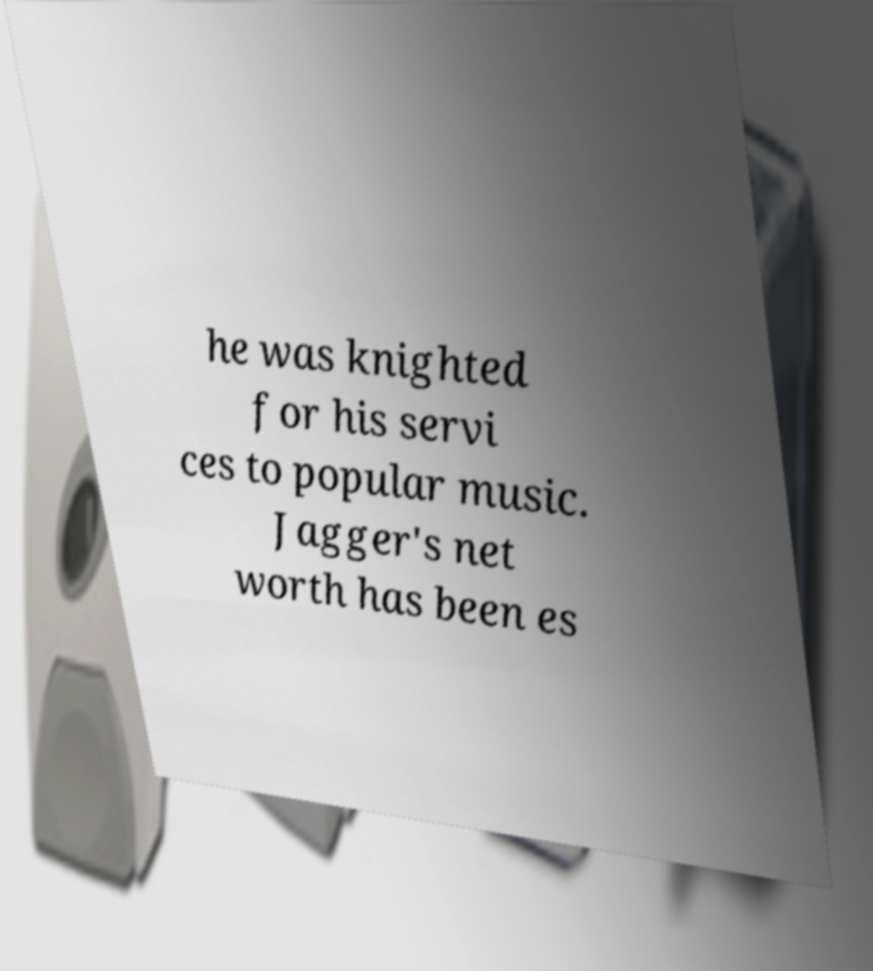Could you extract and type out the text from this image? he was knighted for his servi ces to popular music. Jagger's net worth has been es 